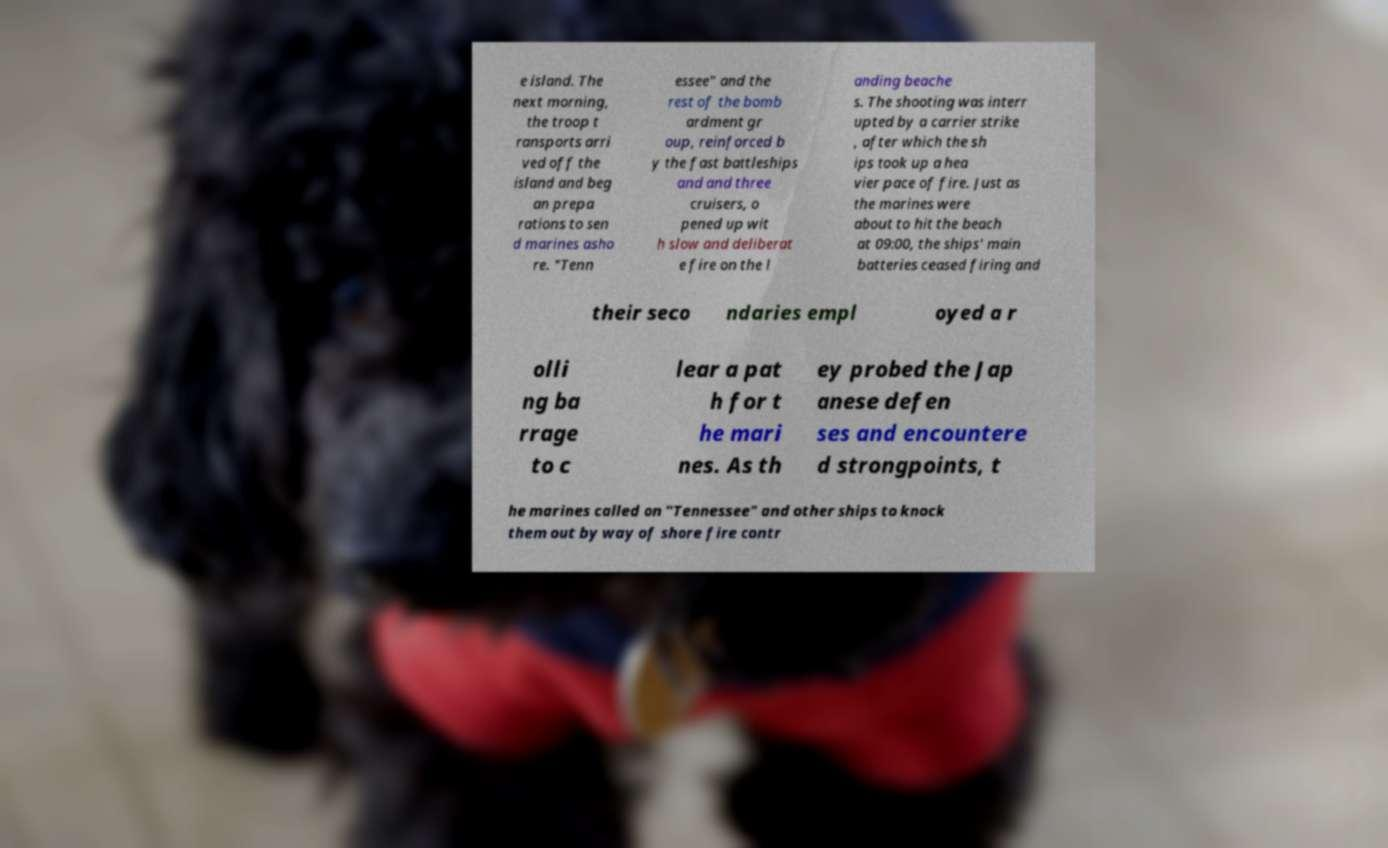Please identify and transcribe the text found in this image. e island. The next morning, the troop t ransports arri ved off the island and beg an prepa rations to sen d marines asho re. "Tenn essee" and the rest of the bomb ardment gr oup, reinforced b y the fast battleships and and three cruisers, o pened up wit h slow and deliberat e fire on the l anding beache s. The shooting was interr upted by a carrier strike , after which the sh ips took up a hea vier pace of fire. Just as the marines were about to hit the beach at 09:00, the ships' main batteries ceased firing and their seco ndaries empl oyed a r olli ng ba rrage to c lear a pat h for t he mari nes. As th ey probed the Jap anese defen ses and encountere d strongpoints, t he marines called on "Tennessee" and other ships to knock them out by way of shore fire contr 